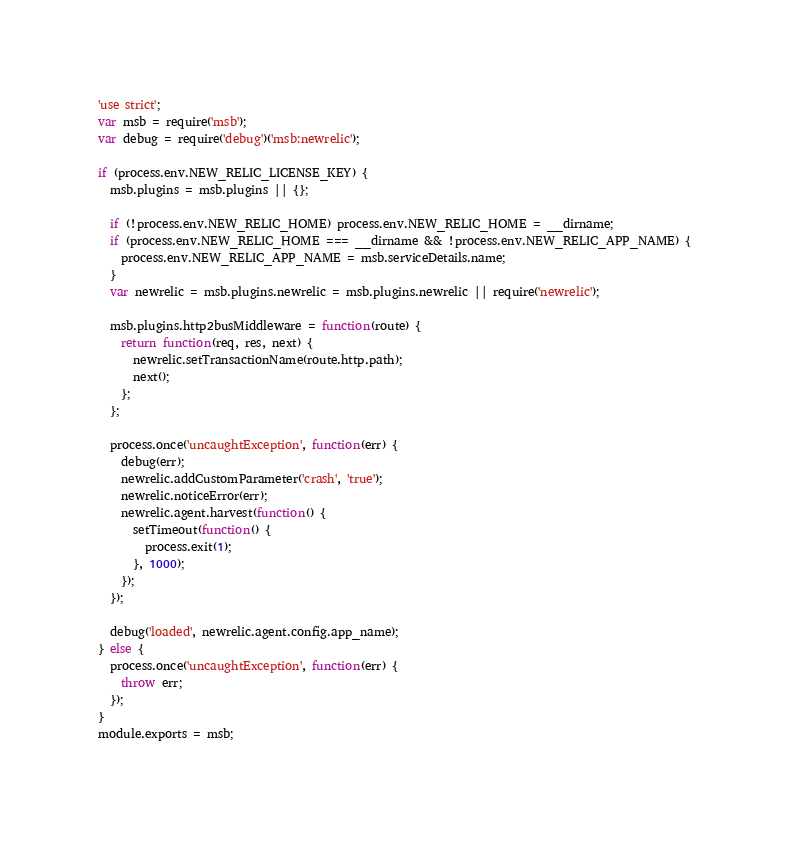Convert code to text. <code><loc_0><loc_0><loc_500><loc_500><_JavaScript_>'use strict';
var msb = require('msb');
var debug = require('debug')('msb:newrelic');

if (process.env.NEW_RELIC_LICENSE_KEY) {
  msb.plugins = msb.plugins || {};

  if (!process.env.NEW_RELIC_HOME) process.env.NEW_RELIC_HOME = __dirname;
  if (process.env.NEW_RELIC_HOME === __dirname && !process.env.NEW_RELIC_APP_NAME) {
    process.env.NEW_RELIC_APP_NAME = msb.serviceDetails.name;
  }
  var newrelic = msb.plugins.newrelic = msb.plugins.newrelic || require('newrelic');

  msb.plugins.http2busMiddleware = function(route) {
    return function(req, res, next) {
      newrelic.setTransactionName(route.http.path);
      next();
    };
  };

  process.once('uncaughtException', function(err) {
    debug(err);
    newrelic.addCustomParameter('crash', 'true');
    newrelic.noticeError(err);
    newrelic.agent.harvest(function() {
      setTimeout(function() {
        process.exit(1);
      }, 1000);
    });
  });

  debug('loaded', newrelic.agent.config.app_name);
} else {
  process.once('uncaughtException', function(err) {
    throw err;
  });
}
module.exports = msb;
</code> 